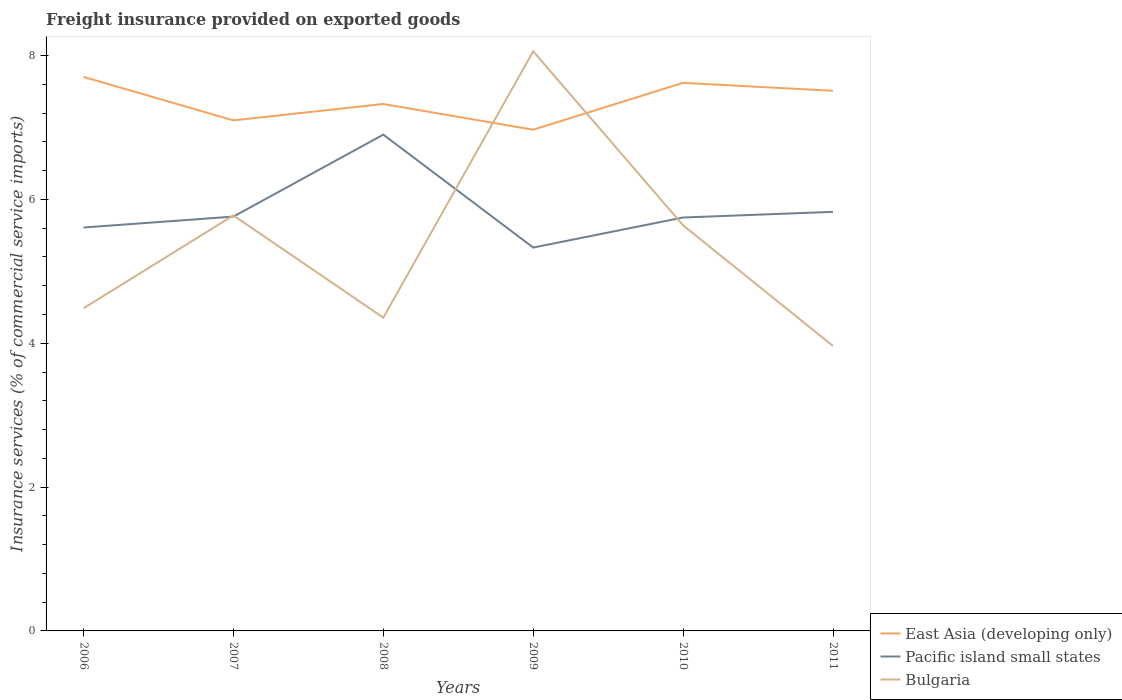Is the number of lines equal to the number of legend labels?
Provide a short and direct response. Yes. Across all years, what is the maximum freight insurance provided on exported goods in Bulgaria?
Provide a short and direct response. 3.96. What is the total freight insurance provided on exported goods in Bulgaria in the graph?
Your response must be concise. -1.28. What is the difference between the highest and the second highest freight insurance provided on exported goods in Pacific island small states?
Make the answer very short. 1.57. What is the difference between the highest and the lowest freight insurance provided on exported goods in Pacific island small states?
Provide a short and direct response. 1. Is the freight insurance provided on exported goods in East Asia (developing only) strictly greater than the freight insurance provided on exported goods in Bulgaria over the years?
Provide a short and direct response. No. How many years are there in the graph?
Provide a short and direct response. 6. What is the difference between two consecutive major ticks on the Y-axis?
Provide a short and direct response. 2. Does the graph contain any zero values?
Keep it short and to the point. No. Where does the legend appear in the graph?
Provide a succinct answer. Bottom right. What is the title of the graph?
Your answer should be very brief. Freight insurance provided on exported goods. What is the label or title of the Y-axis?
Ensure brevity in your answer.  Insurance services (% of commercial service imports). What is the Insurance services (% of commercial service imports) of East Asia (developing only) in 2006?
Offer a terse response. 7.7. What is the Insurance services (% of commercial service imports) in Pacific island small states in 2006?
Your response must be concise. 5.61. What is the Insurance services (% of commercial service imports) in Bulgaria in 2006?
Keep it short and to the point. 4.49. What is the Insurance services (% of commercial service imports) in East Asia (developing only) in 2007?
Offer a terse response. 7.1. What is the Insurance services (% of commercial service imports) of Pacific island small states in 2007?
Your answer should be compact. 5.76. What is the Insurance services (% of commercial service imports) in Bulgaria in 2007?
Provide a short and direct response. 5.78. What is the Insurance services (% of commercial service imports) of East Asia (developing only) in 2008?
Your answer should be very brief. 7.33. What is the Insurance services (% of commercial service imports) of Pacific island small states in 2008?
Ensure brevity in your answer.  6.9. What is the Insurance services (% of commercial service imports) of Bulgaria in 2008?
Ensure brevity in your answer.  4.36. What is the Insurance services (% of commercial service imports) of East Asia (developing only) in 2009?
Keep it short and to the point. 6.97. What is the Insurance services (% of commercial service imports) of Pacific island small states in 2009?
Your answer should be very brief. 5.33. What is the Insurance services (% of commercial service imports) of Bulgaria in 2009?
Provide a succinct answer. 8.06. What is the Insurance services (% of commercial service imports) in East Asia (developing only) in 2010?
Ensure brevity in your answer.  7.62. What is the Insurance services (% of commercial service imports) in Pacific island small states in 2010?
Your answer should be very brief. 5.75. What is the Insurance services (% of commercial service imports) of Bulgaria in 2010?
Provide a succinct answer. 5.64. What is the Insurance services (% of commercial service imports) of East Asia (developing only) in 2011?
Provide a short and direct response. 7.51. What is the Insurance services (% of commercial service imports) of Pacific island small states in 2011?
Make the answer very short. 5.83. What is the Insurance services (% of commercial service imports) of Bulgaria in 2011?
Make the answer very short. 3.96. Across all years, what is the maximum Insurance services (% of commercial service imports) of East Asia (developing only)?
Keep it short and to the point. 7.7. Across all years, what is the maximum Insurance services (% of commercial service imports) of Pacific island small states?
Your answer should be compact. 6.9. Across all years, what is the maximum Insurance services (% of commercial service imports) in Bulgaria?
Provide a short and direct response. 8.06. Across all years, what is the minimum Insurance services (% of commercial service imports) in East Asia (developing only)?
Provide a succinct answer. 6.97. Across all years, what is the minimum Insurance services (% of commercial service imports) of Pacific island small states?
Provide a short and direct response. 5.33. Across all years, what is the minimum Insurance services (% of commercial service imports) of Bulgaria?
Provide a succinct answer. 3.96. What is the total Insurance services (% of commercial service imports) of East Asia (developing only) in the graph?
Your response must be concise. 44.23. What is the total Insurance services (% of commercial service imports) in Pacific island small states in the graph?
Your response must be concise. 35.18. What is the total Insurance services (% of commercial service imports) in Bulgaria in the graph?
Your response must be concise. 32.28. What is the difference between the Insurance services (% of commercial service imports) of East Asia (developing only) in 2006 and that in 2007?
Your answer should be very brief. 0.6. What is the difference between the Insurance services (% of commercial service imports) of Pacific island small states in 2006 and that in 2007?
Offer a very short reply. -0.15. What is the difference between the Insurance services (% of commercial service imports) in Bulgaria in 2006 and that in 2007?
Give a very brief answer. -1.29. What is the difference between the Insurance services (% of commercial service imports) in East Asia (developing only) in 2006 and that in 2008?
Offer a terse response. 0.38. What is the difference between the Insurance services (% of commercial service imports) of Pacific island small states in 2006 and that in 2008?
Ensure brevity in your answer.  -1.29. What is the difference between the Insurance services (% of commercial service imports) of Bulgaria in 2006 and that in 2008?
Your answer should be compact. 0.13. What is the difference between the Insurance services (% of commercial service imports) of East Asia (developing only) in 2006 and that in 2009?
Offer a terse response. 0.73. What is the difference between the Insurance services (% of commercial service imports) of Pacific island small states in 2006 and that in 2009?
Provide a succinct answer. 0.28. What is the difference between the Insurance services (% of commercial service imports) of Bulgaria in 2006 and that in 2009?
Ensure brevity in your answer.  -3.57. What is the difference between the Insurance services (% of commercial service imports) in East Asia (developing only) in 2006 and that in 2010?
Your response must be concise. 0.08. What is the difference between the Insurance services (% of commercial service imports) of Pacific island small states in 2006 and that in 2010?
Ensure brevity in your answer.  -0.14. What is the difference between the Insurance services (% of commercial service imports) in Bulgaria in 2006 and that in 2010?
Provide a short and direct response. -1.15. What is the difference between the Insurance services (% of commercial service imports) of East Asia (developing only) in 2006 and that in 2011?
Make the answer very short. 0.19. What is the difference between the Insurance services (% of commercial service imports) in Pacific island small states in 2006 and that in 2011?
Keep it short and to the point. -0.22. What is the difference between the Insurance services (% of commercial service imports) in Bulgaria in 2006 and that in 2011?
Ensure brevity in your answer.  0.52. What is the difference between the Insurance services (% of commercial service imports) in East Asia (developing only) in 2007 and that in 2008?
Provide a short and direct response. -0.23. What is the difference between the Insurance services (% of commercial service imports) in Pacific island small states in 2007 and that in 2008?
Your response must be concise. -1.14. What is the difference between the Insurance services (% of commercial service imports) in Bulgaria in 2007 and that in 2008?
Provide a succinct answer. 1.42. What is the difference between the Insurance services (% of commercial service imports) in East Asia (developing only) in 2007 and that in 2009?
Your answer should be very brief. 0.13. What is the difference between the Insurance services (% of commercial service imports) of Pacific island small states in 2007 and that in 2009?
Make the answer very short. 0.43. What is the difference between the Insurance services (% of commercial service imports) of Bulgaria in 2007 and that in 2009?
Provide a short and direct response. -2.28. What is the difference between the Insurance services (% of commercial service imports) in East Asia (developing only) in 2007 and that in 2010?
Provide a succinct answer. -0.52. What is the difference between the Insurance services (% of commercial service imports) in Pacific island small states in 2007 and that in 2010?
Make the answer very short. 0.01. What is the difference between the Insurance services (% of commercial service imports) in Bulgaria in 2007 and that in 2010?
Keep it short and to the point. 0.14. What is the difference between the Insurance services (% of commercial service imports) of East Asia (developing only) in 2007 and that in 2011?
Keep it short and to the point. -0.41. What is the difference between the Insurance services (% of commercial service imports) in Pacific island small states in 2007 and that in 2011?
Keep it short and to the point. -0.07. What is the difference between the Insurance services (% of commercial service imports) of Bulgaria in 2007 and that in 2011?
Offer a terse response. 1.82. What is the difference between the Insurance services (% of commercial service imports) in East Asia (developing only) in 2008 and that in 2009?
Provide a succinct answer. 0.36. What is the difference between the Insurance services (% of commercial service imports) of Pacific island small states in 2008 and that in 2009?
Offer a terse response. 1.57. What is the difference between the Insurance services (% of commercial service imports) of Bulgaria in 2008 and that in 2009?
Offer a very short reply. -3.7. What is the difference between the Insurance services (% of commercial service imports) in East Asia (developing only) in 2008 and that in 2010?
Your answer should be very brief. -0.29. What is the difference between the Insurance services (% of commercial service imports) in Pacific island small states in 2008 and that in 2010?
Give a very brief answer. 1.15. What is the difference between the Insurance services (% of commercial service imports) in Bulgaria in 2008 and that in 2010?
Offer a very short reply. -1.28. What is the difference between the Insurance services (% of commercial service imports) in East Asia (developing only) in 2008 and that in 2011?
Provide a short and direct response. -0.18. What is the difference between the Insurance services (% of commercial service imports) of Pacific island small states in 2008 and that in 2011?
Your response must be concise. 1.07. What is the difference between the Insurance services (% of commercial service imports) in Bulgaria in 2008 and that in 2011?
Make the answer very short. 0.39. What is the difference between the Insurance services (% of commercial service imports) of East Asia (developing only) in 2009 and that in 2010?
Your answer should be compact. -0.65. What is the difference between the Insurance services (% of commercial service imports) in Pacific island small states in 2009 and that in 2010?
Make the answer very short. -0.42. What is the difference between the Insurance services (% of commercial service imports) in Bulgaria in 2009 and that in 2010?
Offer a terse response. 2.42. What is the difference between the Insurance services (% of commercial service imports) in East Asia (developing only) in 2009 and that in 2011?
Offer a very short reply. -0.54. What is the difference between the Insurance services (% of commercial service imports) in Pacific island small states in 2009 and that in 2011?
Give a very brief answer. -0.5. What is the difference between the Insurance services (% of commercial service imports) in Bulgaria in 2009 and that in 2011?
Offer a very short reply. 4.1. What is the difference between the Insurance services (% of commercial service imports) in East Asia (developing only) in 2010 and that in 2011?
Your answer should be very brief. 0.11. What is the difference between the Insurance services (% of commercial service imports) of Pacific island small states in 2010 and that in 2011?
Ensure brevity in your answer.  -0.08. What is the difference between the Insurance services (% of commercial service imports) of Bulgaria in 2010 and that in 2011?
Provide a succinct answer. 1.68. What is the difference between the Insurance services (% of commercial service imports) in East Asia (developing only) in 2006 and the Insurance services (% of commercial service imports) in Pacific island small states in 2007?
Your answer should be compact. 1.94. What is the difference between the Insurance services (% of commercial service imports) of East Asia (developing only) in 2006 and the Insurance services (% of commercial service imports) of Bulgaria in 2007?
Your answer should be compact. 1.93. What is the difference between the Insurance services (% of commercial service imports) in Pacific island small states in 2006 and the Insurance services (% of commercial service imports) in Bulgaria in 2007?
Provide a short and direct response. -0.17. What is the difference between the Insurance services (% of commercial service imports) in East Asia (developing only) in 2006 and the Insurance services (% of commercial service imports) in Pacific island small states in 2008?
Ensure brevity in your answer.  0.8. What is the difference between the Insurance services (% of commercial service imports) in East Asia (developing only) in 2006 and the Insurance services (% of commercial service imports) in Bulgaria in 2008?
Ensure brevity in your answer.  3.35. What is the difference between the Insurance services (% of commercial service imports) in Pacific island small states in 2006 and the Insurance services (% of commercial service imports) in Bulgaria in 2008?
Provide a succinct answer. 1.25. What is the difference between the Insurance services (% of commercial service imports) of East Asia (developing only) in 2006 and the Insurance services (% of commercial service imports) of Pacific island small states in 2009?
Offer a very short reply. 2.37. What is the difference between the Insurance services (% of commercial service imports) of East Asia (developing only) in 2006 and the Insurance services (% of commercial service imports) of Bulgaria in 2009?
Your answer should be very brief. -0.36. What is the difference between the Insurance services (% of commercial service imports) in Pacific island small states in 2006 and the Insurance services (% of commercial service imports) in Bulgaria in 2009?
Ensure brevity in your answer.  -2.45. What is the difference between the Insurance services (% of commercial service imports) in East Asia (developing only) in 2006 and the Insurance services (% of commercial service imports) in Pacific island small states in 2010?
Offer a terse response. 1.96. What is the difference between the Insurance services (% of commercial service imports) in East Asia (developing only) in 2006 and the Insurance services (% of commercial service imports) in Bulgaria in 2010?
Offer a very short reply. 2.06. What is the difference between the Insurance services (% of commercial service imports) of Pacific island small states in 2006 and the Insurance services (% of commercial service imports) of Bulgaria in 2010?
Your answer should be very brief. -0.03. What is the difference between the Insurance services (% of commercial service imports) of East Asia (developing only) in 2006 and the Insurance services (% of commercial service imports) of Pacific island small states in 2011?
Provide a succinct answer. 1.88. What is the difference between the Insurance services (% of commercial service imports) in East Asia (developing only) in 2006 and the Insurance services (% of commercial service imports) in Bulgaria in 2011?
Provide a short and direct response. 3.74. What is the difference between the Insurance services (% of commercial service imports) in Pacific island small states in 2006 and the Insurance services (% of commercial service imports) in Bulgaria in 2011?
Your response must be concise. 1.65. What is the difference between the Insurance services (% of commercial service imports) in East Asia (developing only) in 2007 and the Insurance services (% of commercial service imports) in Pacific island small states in 2008?
Keep it short and to the point. 0.2. What is the difference between the Insurance services (% of commercial service imports) in East Asia (developing only) in 2007 and the Insurance services (% of commercial service imports) in Bulgaria in 2008?
Ensure brevity in your answer.  2.74. What is the difference between the Insurance services (% of commercial service imports) in Pacific island small states in 2007 and the Insurance services (% of commercial service imports) in Bulgaria in 2008?
Your response must be concise. 1.41. What is the difference between the Insurance services (% of commercial service imports) in East Asia (developing only) in 2007 and the Insurance services (% of commercial service imports) in Pacific island small states in 2009?
Provide a short and direct response. 1.77. What is the difference between the Insurance services (% of commercial service imports) of East Asia (developing only) in 2007 and the Insurance services (% of commercial service imports) of Bulgaria in 2009?
Give a very brief answer. -0.96. What is the difference between the Insurance services (% of commercial service imports) of Pacific island small states in 2007 and the Insurance services (% of commercial service imports) of Bulgaria in 2009?
Ensure brevity in your answer.  -2.3. What is the difference between the Insurance services (% of commercial service imports) in East Asia (developing only) in 2007 and the Insurance services (% of commercial service imports) in Pacific island small states in 2010?
Offer a terse response. 1.35. What is the difference between the Insurance services (% of commercial service imports) of East Asia (developing only) in 2007 and the Insurance services (% of commercial service imports) of Bulgaria in 2010?
Keep it short and to the point. 1.46. What is the difference between the Insurance services (% of commercial service imports) of Pacific island small states in 2007 and the Insurance services (% of commercial service imports) of Bulgaria in 2010?
Ensure brevity in your answer.  0.12. What is the difference between the Insurance services (% of commercial service imports) of East Asia (developing only) in 2007 and the Insurance services (% of commercial service imports) of Pacific island small states in 2011?
Provide a short and direct response. 1.27. What is the difference between the Insurance services (% of commercial service imports) in East Asia (developing only) in 2007 and the Insurance services (% of commercial service imports) in Bulgaria in 2011?
Give a very brief answer. 3.14. What is the difference between the Insurance services (% of commercial service imports) of Pacific island small states in 2007 and the Insurance services (% of commercial service imports) of Bulgaria in 2011?
Offer a terse response. 1.8. What is the difference between the Insurance services (% of commercial service imports) of East Asia (developing only) in 2008 and the Insurance services (% of commercial service imports) of Pacific island small states in 2009?
Keep it short and to the point. 2. What is the difference between the Insurance services (% of commercial service imports) in East Asia (developing only) in 2008 and the Insurance services (% of commercial service imports) in Bulgaria in 2009?
Provide a succinct answer. -0.73. What is the difference between the Insurance services (% of commercial service imports) of Pacific island small states in 2008 and the Insurance services (% of commercial service imports) of Bulgaria in 2009?
Offer a very short reply. -1.16. What is the difference between the Insurance services (% of commercial service imports) of East Asia (developing only) in 2008 and the Insurance services (% of commercial service imports) of Pacific island small states in 2010?
Provide a succinct answer. 1.58. What is the difference between the Insurance services (% of commercial service imports) of East Asia (developing only) in 2008 and the Insurance services (% of commercial service imports) of Bulgaria in 2010?
Your answer should be compact. 1.69. What is the difference between the Insurance services (% of commercial service imports) of Pacific island small states in 2008 and the Insurance services (% of commercial service imports) of Bulgaria in 2010?
Offer a terse response. 1.26. What is the difference between the Insurance services (% of commercial service imports) of East Asia (developing only) in 2008 and the Insurance services (% of commercial service imports) of Pacific island small states in 2011?
Make the answer very short. 1.5. What is the difference between the Insurance services (% of commercial service imports) of East Asia (developing only) in 2008 and the Insurance services (% of commercial service imports) of Bulgaria in 2011?
Keep it short and to the point. 3.36. What is the difference between the Insurance services (% of commercial service imports) in Pacific island small states in 2008 and the Insurance services (% of commercial service imports) in Bulgaria in 2011?
Make the answer very short. 2.94. What is the difference between the Insurance services (% of commercial service imports) in East Asia (developing only) in 2009 and the Insurance services (% of commercial service imports) in Pacific island small states in 2010?
Your answer should be compact. 1.22. What is the difference between the Insurance services (% of commercial service imports) of East Asia (developing only) in 2009 and the Insurance services (% of commercial service imports) of Bulgaria in 2010?
Provide a short and direct response. 1.33. What is the difference between the Insurance services (% of commercial service imports) in Pacific island small states in 2009 and the Insurance services (% of commercial service imports) in Bulgaria in 2010?
Ensure brevity in your answer.  -0.31. What is the difference between the Insurance services (% of commercial service imports) in East Asia (developing only) in 2009 and the Insurance services (% of commercial service imports) in Pacific island small states in 2011?
Your response must be concise. 1.14. What is the difference between the Insurance services (% of commercial service imports) in East Asia (developing only) in 2009 and the Insurance services (% of commercial service imports) in Bulgaria in 2011?
Your response must be concise. 3.01. What is the difference between the Insurance services (% of commercial service imports) in Pacific island small states in 2009 and the Insurance services (% of commercial service imports) in Bulgaria in 2011?
Keep it short and to the point. 1.37. What is the difference between the Insurance services (% of commercial service imports) of East Asia (developing only) in 2010 and the Insurance services (% of commercial service imports) of Pacific island small states in 2011?
Your response must be concise. 1.79. What is the difference between the Insurance services (% of commercial service imports) in East Asia (developing only) in 2010 and the Insurance services (% of commercial service imports) in Bulgaria in 2011?
Offer a terse response. 3.66. What is the difference between the Insurance services (% of commercial service imports) of Pacific island small states in 2010 and the Insurance services (% of commercial service imports) of Bulgaria in 2011?
Ensure brevity in your answer.  1.79. What is the average Insurance services (% of commercial service imports) of East Asia (developing only) per year?
Your answer should be very brief. 7.37. What is the average Insurance services (% of commercial service imports) in Pacific island small states per year?
Give a very brief answer. 5.86. What is the average Insurance services (% of commercial service imports) in Bulgaria per year?
Provide a short and direct response. 5.38. In the year 2006, what is the difference between the Insurance services (% of commercial service imports) of East Asia (developing only) and Insurance services (% of commercial service imports) of Pacific island small states?
Ensure brevity in your answer.  2.09. In the year 2006, what is the difference between the Insurance services (% of commercial service imports) in East Asia (developing only) and Insurance services (% of commercial service imports) in Bulgaria?
Provide a succinct answer. 3.22. In the year 2006, what is the difference between the Insurance services (% of commercial service imports) in Pacific island small states and Insurance services (% of commercial service imports) in Bulgaria?
Make the answer very short. 1.12. In the year 2007, what is the difference between the Insurance services (% of commercial service imports) of East Asia (developing only) and Insurance services (% of commercial service imports) of Pacific island small states?
Provide a short and direct response. 1.34. In the year 2007, what is the difference between the Insurance services (% of commercial service imports) of East Asia (developing only) and Insurance services (% of commercial service imports) of Bulgaria?
Offer a very short reply. 1.32. In the year 2007, what is the difference between the Insurance services (% of commercial service imports) of Pacific island small states and Insurance services (% of commercial service imports) of Bulgaria?
Offer a terse response. -0.02. In the year 2008, what is the difference between the Insurance services (% of commercial service imports) of East Asia (developing only) and Insurance services (% of commercial service imports) of Pacific island small states?
Your answer should be compact. 0.43. In the year 2008, what is the difference between the Insurance services (% of commercial service imports) of East Asia (developing only) and Insurance services (% of commercial service imports) of Bulgaria?
Your answer should be very brief. 2.97. In the year 2008, what is the difference between the Insurance services (% of commercial service imports) of Pacific island small states and Insurance services (% of commercial service imports) of Bulgaria?
Ensure brevity in your answer.  2.55. In the year 2009, what is the difference between the Insurance services (% of commercial service imports) of East Asia (developing only) and Insurance services (% of commercial service imports) of Pacific island small states?
Keep it short and to the point. 1.64. In the year 2009, what is the difference between the Insurance services (% of commercial service imports) of East Asia (developing only) and Insurance services (% of commercial service imports) of Bulgaria?
Ensure brevity in your answer.  -1.09. In the year 2009, what is the difference between the Insurance services (% of commercial service imports) in Pacific island small states and Insurance services (% of commercial service imports) in Bulgaria?
Ensure brevity in your answer.  -2.73. In the year 2010, what is the difference between the Insurance services (% of commercial service imports) in East Asia (developing only) and Insurance services (% of commercial service imports) in Pacific island small states?
Your response must be concise. 1.87. In the year 2010, what is the difference between the Insurance services (% of commercial service imports) in East Asia (developing only) and Insurance services (% of commercial service imports) in Bulgaria?
Your response must be concise. 1.98. In the year 2010, what is the difference between the Insurance services (% of commercial service imports) in Pacific island small states and Insurance services (% of commercial service imports) in Bulgaria?
Ensure brevity in your answer.  0.11. In the year 2011, what is the difference between the Insurance services (% of commercial service imports) of East Asia (developing only) and Insurance services (% of commercial service imports) of Pacific island small states?
Your answer should be compact. 1.68. In the year 2011, what is the difference between the Insurance services (% of commercial service imports) of East Asia (developing only) and Insurance services (% of commercial service imports) of Bulgaria?
Keep it short and to the point. 3.55. In the year 2011, what is the difference between the Insurance services (% of commercial service imports) of Pacific island small states and Insurance services (% of commercial service imports) of Bulgaria?
Keep it short and to the point. 1.86. What is the ratio of the Insurance services (% of commercial service imports) in East Asia (developing only) in 2006 to that in 2007?
Your answer should be compact. 1.09. What is the ratio of the Insurance services (% of commercial service imports) of Pacific island small states in 2006 to that in 2007?
Keep it short and to the point. 0.97. What is the ratio of the Insurance services (% of commercial service imports) in Bulgaria in 2006 to that in 2007?
Your answer should be compact. 0.78. What is the ratio of the Insurance services (% of commercial service imports) of East Asia (developing only) in 2006 to that in 2008?
Keep it short and to the point. 1.05. What is the ratio of the Insurance services (% of commercial service imports) of Pacific island small states in 2006 to that in 2008?
Offer a very short reply. 0.81. What is the ratio of the Insurance services (% of commercial service imports) in Bulgaria in 2006 to that in 2008?
Give a very brief answer. 1.03. What is the ratio of the Insurance services (% of commercial service imports) of East Asia (developing only) in 2006 to that in 2009?
Ensure brevity in your answer.  1.11. What is the ratio of the Insurance services (% of commercial service imports) in Pacific island small states in 2006 to that in 2009?
Keep it short and to the point. 1.05. What is the ratio of the Insurance services (% of commercial service imports) of Bulgaria in 2006 to that in 2009?
Provide a succinct answer. 0.56. What is the ratio of the Insurance services (% of commercial service imports) of East Asia (developing only) in 2006 to that in 2010?
Your response must be concise. 1.01. What is the ratio of the Insurance services (% of commercial service imports) of Pacific island small states in 2006 to that in 2010?
Keep it short and to the point. 0.98. What is the ratio of the Insurance services (% of commercial service imports) of Bulgaria in 2006 to that in 2010?
Provide a succinct answer. 0.8. What is the ratio of the Insurance services (% of commercial service imports) in East Asia (developing only) in 2006 to that in 2011?
Your response must be concise. 1.03. What is the ratio of the Insurance services (% of commercial service imports) of Pacific island small states in 2006 to that in 2011?
Your answer should be compact. 0.96. What is the ratio of the Insurance services (% of commercial service imports) of Bulgaria in 2006 to that in 2011?
Provide a short and direct response. 1.13. What is the ratio of the Insurance services (% of commercial service imports) of East Asia (developing only) in 2007 to that in 2008?
Make the answer very short. 0.97. What is the ratio of the Insurance services (% of commercial service imports) in Pacific island small states in 2007 to that in 2008?
Your answer should be compact. 0.83. What is the ratio of the Insurance services (% of commercial service imports) in Bulgaria in 2007 to that in 2008?
Offer a terse response. 1.33. What is the ratio of the Insurance services (% of commercial service imports) in East Asia (developing only) in 2007 to that in 2009?
Offer a very short reply. 1.02. What is the ratio of the Insurance services (% of commercial service imports) of Pacific island small states in 2007 to that in 2009?
Offer a terse response. 1.08. What is the ratio of the Insurance services (% of commercial service imports) in Bulgaria in 2007 to that in 2009?
Offer a very short reply. 0.72. What is the ratio of the Insurance services (% of commercial service imports) of East Asia (developing only) in 2007 to that in 2010?
Keep it short and to the point. 0.93. What is the ratio of the Insurance services (% of commercial service imports) of Pacific island small states in 2007 to that in 2010?
Ensure brevity in your answer.  1. What is the ratio of the Insurance services (% of commercial service imports) in Bulgaria in 2007 to that in 2010?
Your answer should be compact. 1.02. What is the ratio of the Insurance services (% of commercial service imports) of East Asia (developing only) in 2007 to that in 2011?
Your response must be concise. 0.95. What is the ratio of the Insurance services (% of commercial service imports) in Pacific island small states in 2007 to that in 2011?
Your response must be concise. 0.99. What is the ratio of the Insurance services (% of commercial service imports) in Bulgaria in 2007 to that in 2011?
Offer a very short reply. 1.46. What is the ratio of the Insurance services (% of commercial service imports) in East Asia (developing only) in 2008 to that in 2009?
Give a very brief answer. 1.05. What is the ratio of the Insurance services (% of commercial service imports) in Pacific island small states in 2008 to that in 2009?
Keep it short and to the point. 1.29. What is the ratio of the Insurance services (% of commercial service imports) in Bulgaria in 2008 to that in 2009?
Make the answer very short. 0.54. What is the ratio of the Insurance services (% of commercial service imports) in East Asia (developing only) in 2008 to that in 2010?
Give a very brief answer. 0.96. What is the ratio of the Insurance services (% of commercial service imports) of Pacific island small states in 2008 to that in 2010?
Ensure brevity in your answer.  1.2. What is the ratio of the Insurance services (% of commercial service imports) of Bulgaria in 2008 to that in 2010?
Ensure brevity in your answer.  0.77. What is the ratio of the Insurance services (% of commercial service imports) in East Asia (developing only) in 2008 to that in 2011?
Your answer should be very brief. 0.98. What is the ratio of the Insurance services (% of commercial service imports) of Pacific island small states in 2008 to that in 2011?
Give a very brief answer. 1.18. What is the ratio of the Insurance services (% of commercial service imports) of Bulgaria in 2008 to that in 2011?
Make the answer very short. 1.1. What is the ratio of the Insurance services (% of commercial service imports) in East Asia (developing only) in 2009 to that in 2010?
Keep it short and to the point. 0.91. What is the ratio of the Insurance services (% of commercial service imports) of Pacific island small states in 2009 to that in 2010?
Keep it short and to the point. 0.93. What is the ratio of the Insurance services (% of commercial service imports) in Bulgaria in 2009 to that in 2010?
Ensure brevity in your answer.  1.43. What is the ratio of the Insurance services (% of commercial service imports) of East Asia (developing only) in 2009 to that in 2011?
Provide a short and direct response. 0.93. What is the ratio of the Insurance services (% of commercial service imports) in Pacific island small states in 2009 to that in 2011?
Ensure brevity in your answer.  0.91. What is the ratio of the Insurance services (% of commercial service imports) in Bulgaria in 2009 to that in 2011?
Ensure brevity in your answer.  2.03. What is the ratio of the Insurance services (% of commercial service imports) of East Asia (developing only) in 2010 to that in 2011?
Your answer should be compact. 1.01. What is the ratio of the Insurance services (% of commercial service imports) in Pacific island small states in 2010 to that in 2011?
Keep it short and to the point. 0.99. What is the ratio of the Insurance services (% of commercial service imports) of Bulgaria in 2010 to that in 2011?
Give a very brief answer. 1.42. What is the difference between the highest and the second highest Insurance services (% of commercial service imports) of East Asia (developing only)?
Make the answer very short. 0.08. What is the difference between the highest and the second highest Insurance services (% of commercial service imports) in Pacific island small states?
Give a very brief answer. 1.07. What is the difference between the highest and the second highest Insurance services (% of commercial service imports) in Bulgaria?
Provide a short and direct response. 2.28. What is the difference between the highest and the lowest Insurance services (% of commercial service imports) of East Asia (developing only)?
Your answer should be compact. 0.73. What is the difference between the highest and the lowest Insurance services (% of commercial service imports) in Pacific island small states?
Offer a terse response. 1.57. What is the difference between the highest and the lowest Insurance services (% of commercial service imports) of Bulgaria?
Provide a short and direct response. 4.1. 